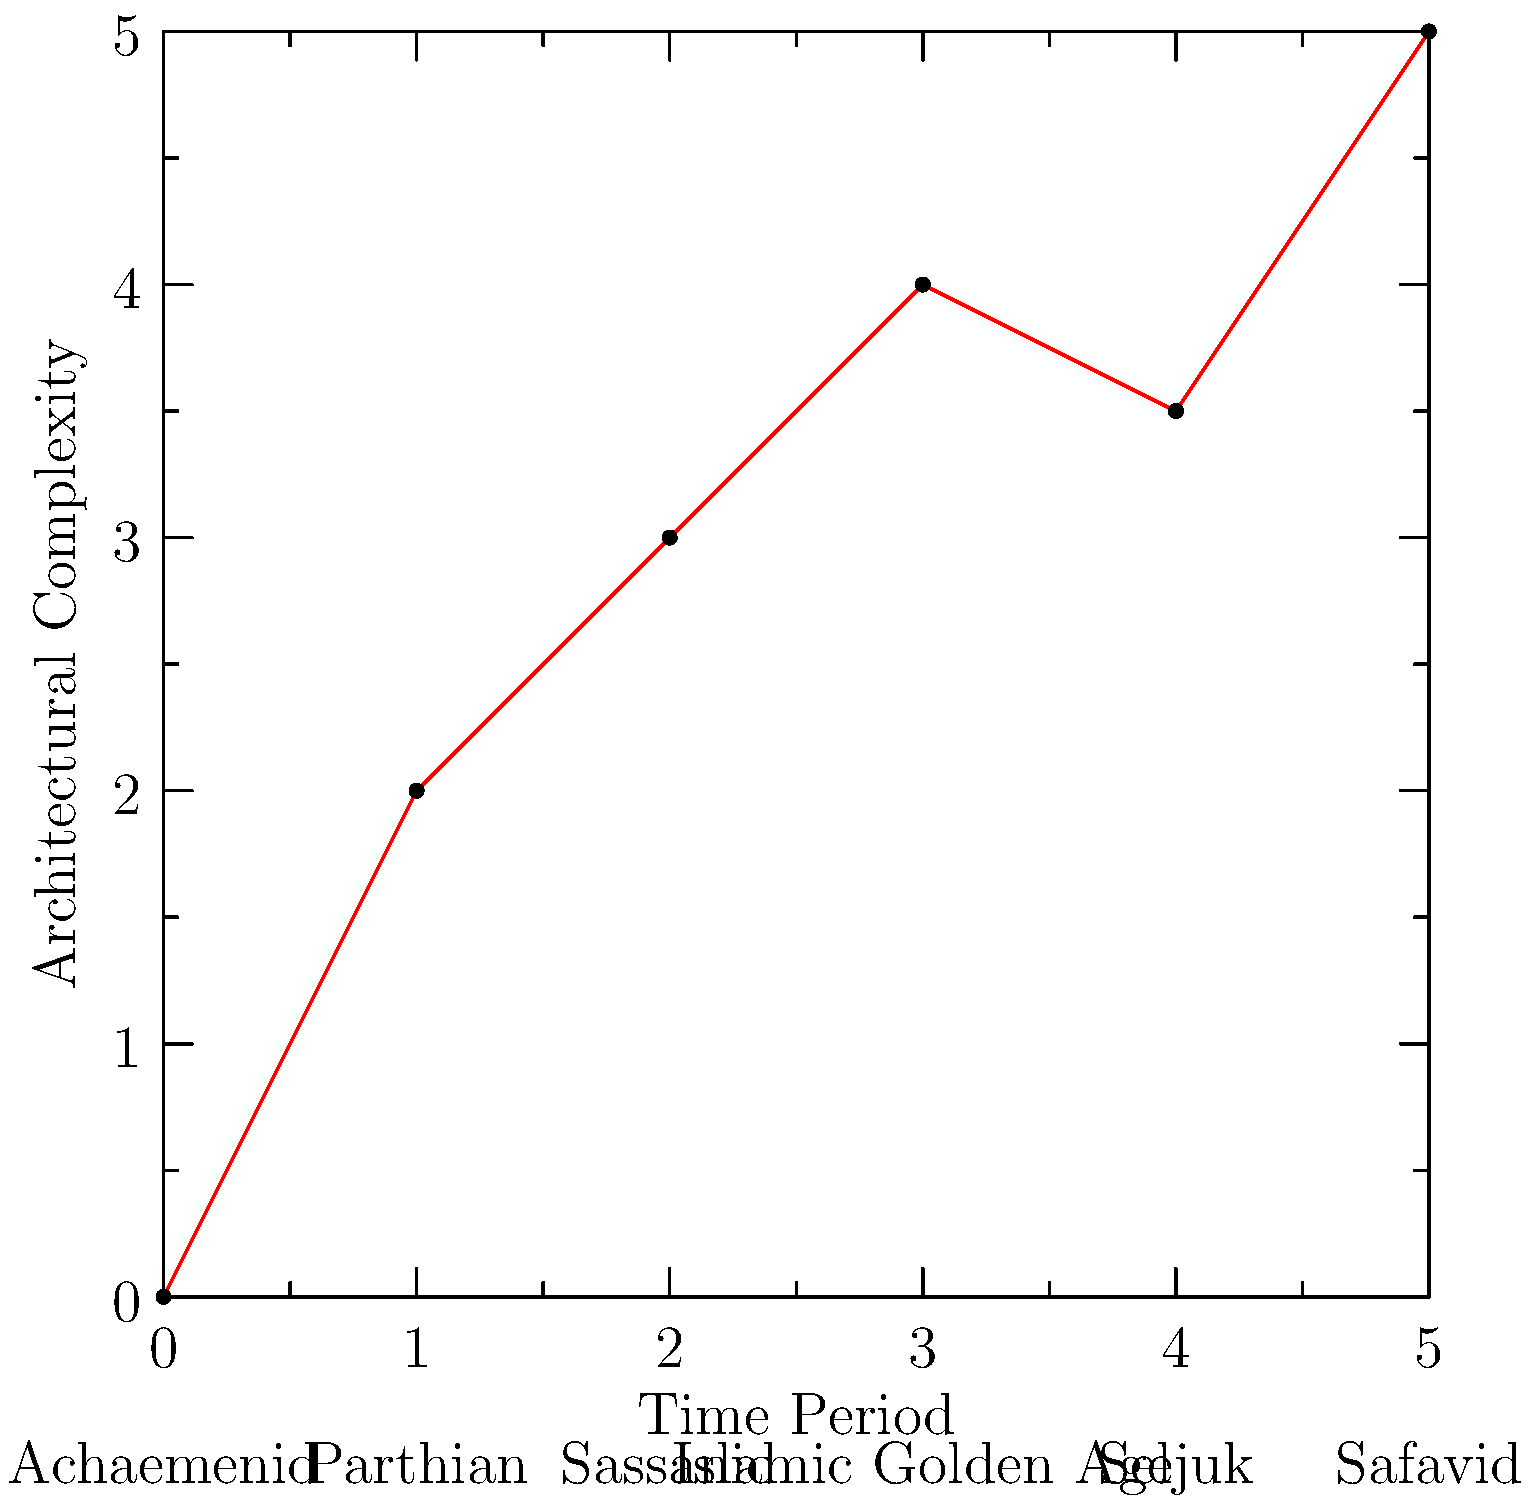Based on the diagram illustrating the evolution of Persian architectural styles through different historical periods, which era marked the most significant increase in architectural complexity compared to its predecessor? To determine which era marked the most significant increase in architectural complexity compared to its predecessor, we need to analyze the slope between each consecutive pair of points:

1. Achaemenid to Parthian: (2 - 0) / (1 - 0) = 2
2. Parthian to Sassanid: (3 - 2) / (2 - 1) = 1
3. Sassanid to Islamic Golden Age: (4 - 3) / (3 - 2) = 1
4. Islamic Golden Age to Seljuk: (3.5 - 4) / (4 - 3) = -0.5 (decrease)
5. Seljuk to Safavid: (5 - 3.5) / (5 - 4) = 1.5

The steepest positive slope indicates the most significant increase in architectural complexity. The largest value is 2, corresponding to the transition from Achaemenid to Parthian era.
Answer: Parthian era 